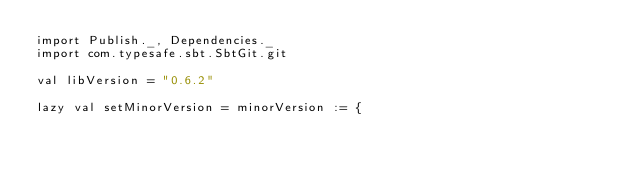Convert code to text. <code><loc_0><loc_0><loc_500><loc_500><_Scala_>import Publish._, Dependencies._
import com.typesafe.sbt.SbtGit.git

val libVersion = "0.6.2"

lazy val setMinorVersion = minorVersion := {</code> 